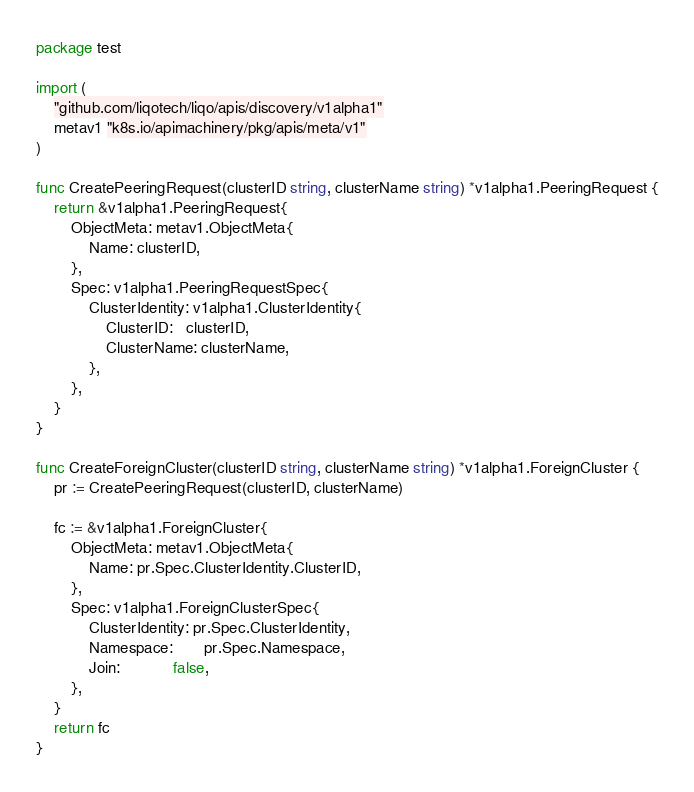<code> <loc_0><loc_0><loc_500><loc_500><_Go_>package test

import (
	"github.com/liqotech/liqo/apis/discovery/v1alpha1"
	metav1 "k8s.io/apimachinery/pkg/apis/meta/v1"
)

func CreatePeeringRequest(clusterID string, clusterName string) *v1alpha1.PeeringRequest {
	return &v1alpha1.PeeringRequest{
		ObjectMeta: metav1.ObjectMeta{
			Name: clusterID,
		},
		Spec: v1alpha1.PeeringRequestSpec{
			ClusterIdentity: v1alpha1.ClusterIdentity{
				ClusterID:   clusterID,
				ClusterName: clusterName,
			},
		},
	}
}

func CreateForeignCluster(clusterID string, clusterName string) *v1alpha1.ForeignCluster {
	pr := CreatePeeringRequest(clusterID, clusterName)

	fc := &v1alpha1.ForeignCluster{
		ObjectMeta: metav1.ObjectMeta{
			Name: pr.Spec.ClusterIdentity.ClusterID,
		},
		Spec: v1alpha1.ForeignClusterSpec{
			ClusterIdentity: pr.Spec.ClusterIdentity,
			Namespace:       pr.Spec.Namespace,
			Join:            false,
		},
	}
	return fc
}
</code> 